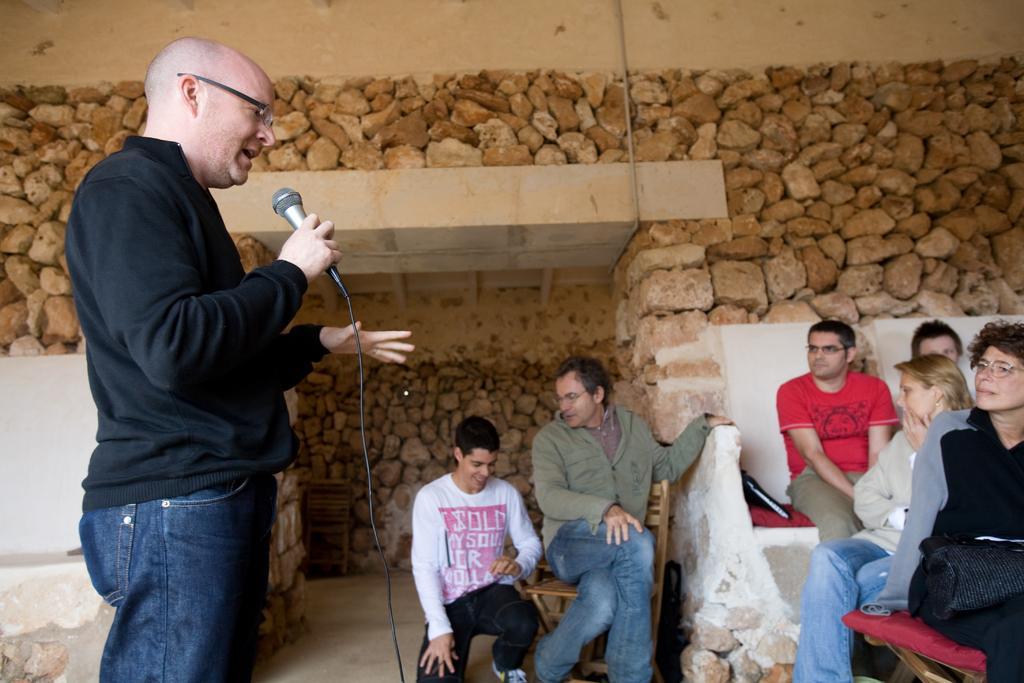Can you describe this image briefly? In this picture there is a man on the left side of the image, by holding a mic in his hand and there are other people on the right side of the image and there are stones in the background area of the image. 